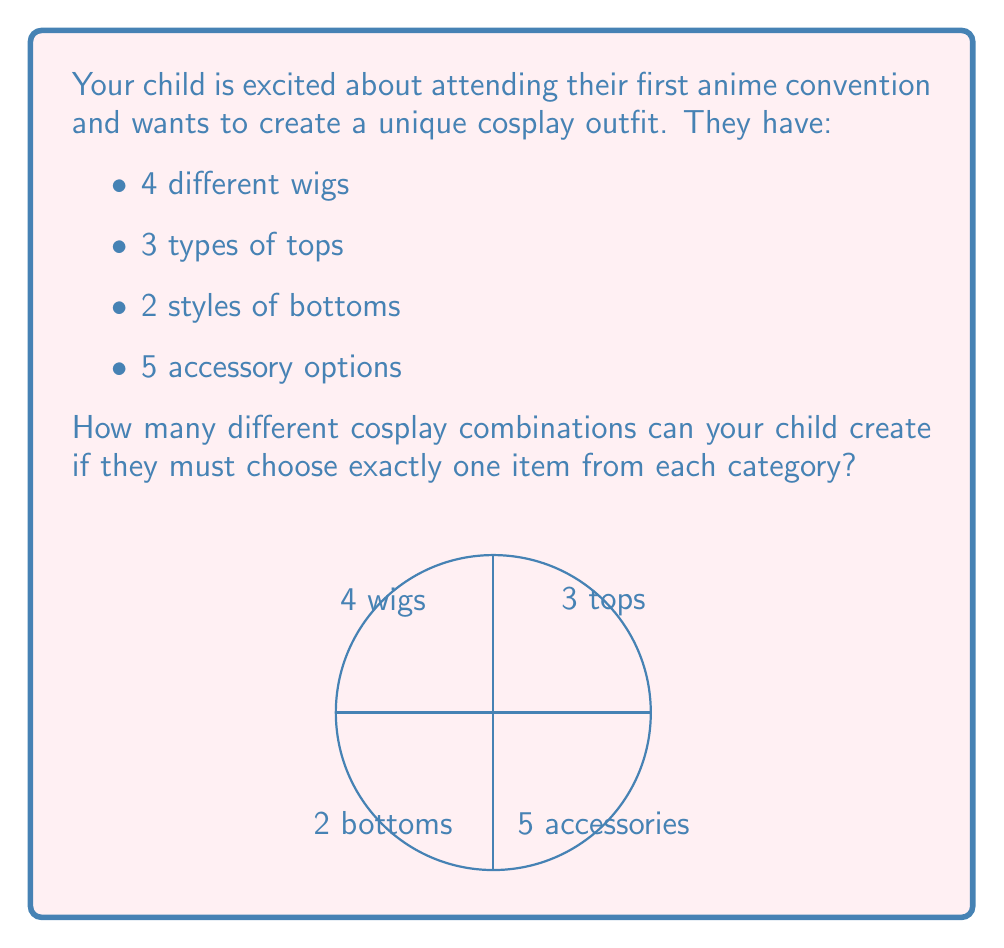Help me with this question. Let's approach this step-by-step using the multiplication principle of counting:

1) For each category, your child must choose exactly one item. The number of ways to make each choice is:
   - Wigs: 4 choices
   - Tops: 3 choices
   - Bottoms: 2 choices
   - Accessories: 5 choices

2) According to the multiplication principle, if we have a sequence of independent choices, the total number of possible outcomes is the product of the number of possibilities for each choice.

3) Therefore, the total number of combinations is:

   $$ 4 \times 3 \times 2 \times 5 $$

4) Let's calculate this:
   $$ 4 \times 3 = 12 $$
   $$ 12 \times 2 = 24 $$
   $$ 24 \times 5 = 120 $$

So, your child can create 120 different cosplay combinations.

This problem demonstrates the concept of combinations in a real-world scenario that aligns with your child's interest in anime and cosplay, making it both educational and engaging.
Answer: 120 combinations 